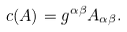Convert formula to latex. <formula><loc_0><loc_0><loc_500><loc_500>c ( A ) = g ^ { \alpha \beta } A _ { \alpha \beta } .</formula> 